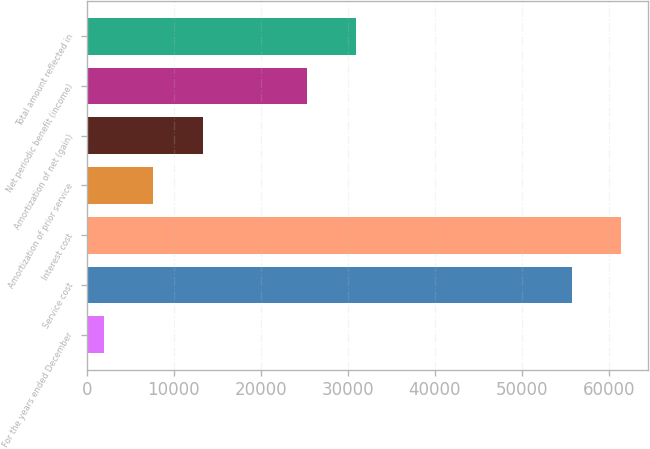<chart> <loc_0><loc_0><loc_500><loc_500><bar_chart><fcel>For the years ended December<fcel>Service cost<fcel>Interest cost<fcel>Amortization of prior service<fcel>Amortization of net (gain)<fcel>Net periodic benefit (income)<fcel>Total amount reflected in<nl><fcel>2006<fcel>55759<fcel>61417<fcel>7664<fcel>13322<fcel>25336<fcel>30994<nl></chart> 